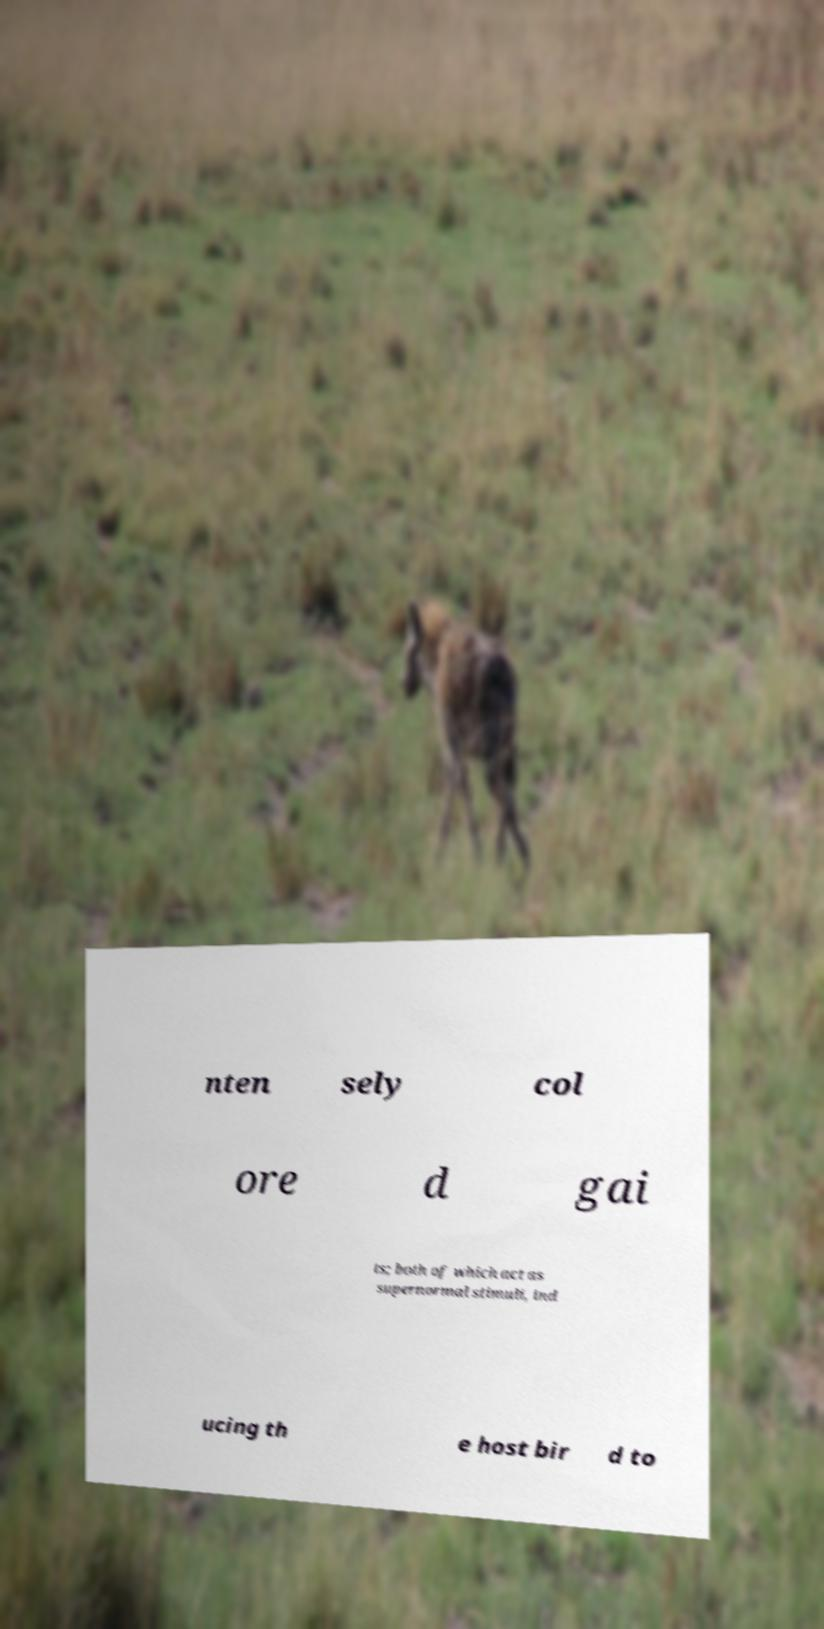Can you accurately transcribe the text from the provided image for me? nten sely col ore d gai ts; both of which act as supernormal stimuli, ind ucing th e host bir d to 